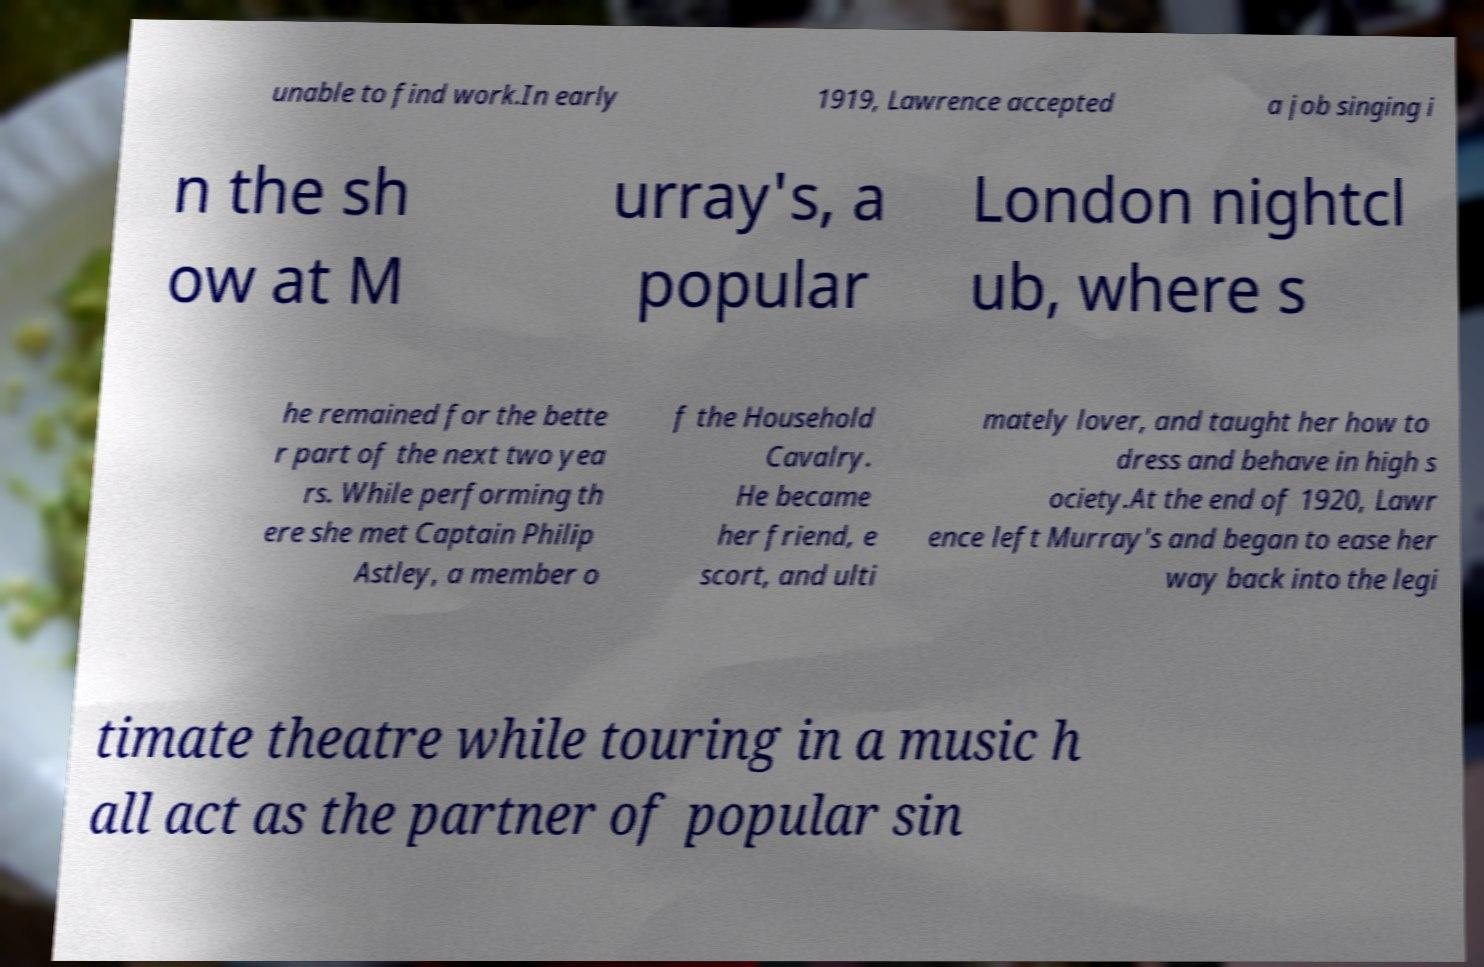Could you assist in decoding the text presented in this image and type it out clearly? unable to find work.In early 1919, Lawrence accepted a job singing i n the sh ow at M urray's, a popular London nightcl ub, where s he remained for the bette r part of the next two yea rs. While performing th ere she met Captain Philip Astley, a member o f the Household Cavalry. He became her friend, e scort, and ulti mately lover, and taught her how to dress and behave in high s ociety.At the end of 1920, Lawr ence left Murray's and began to ease her way back into the legi timate theatre while touring in a music h all act as the partner of popular sin 